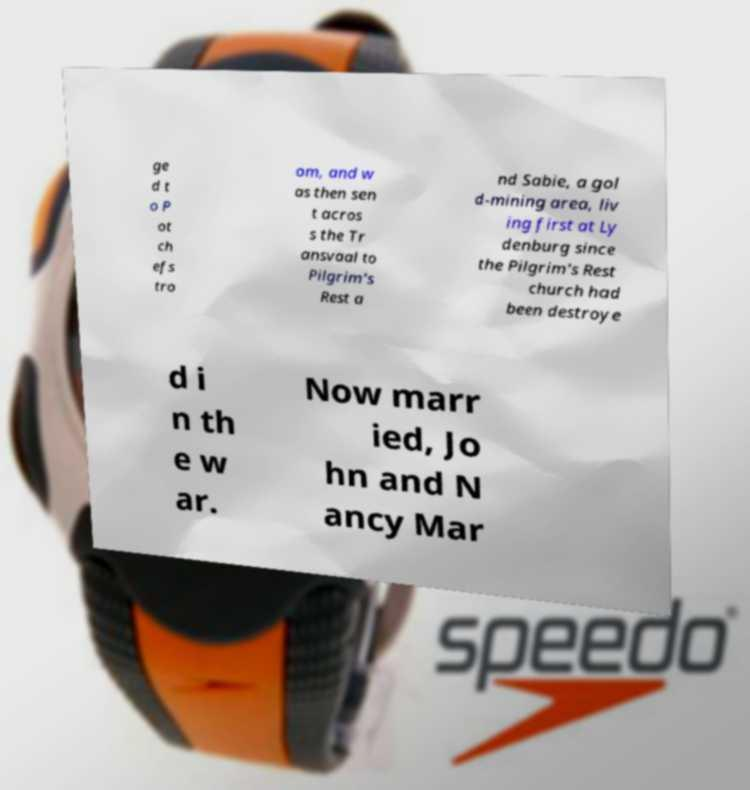There's text embedded in this image that I need extracted. Can you transcribe it verbatim? ge d t o P ot ch efs tro om, and w as then sen t acros s the Tr ansvaal to Pilgrim's Rest a nd Sabie, a gol d-mining area, liv ing first at Ly denburg since the Pilgrim's Rest church had been destroye d i n th e w ar. Now marr ied, Jo hn and N ancy Mar 